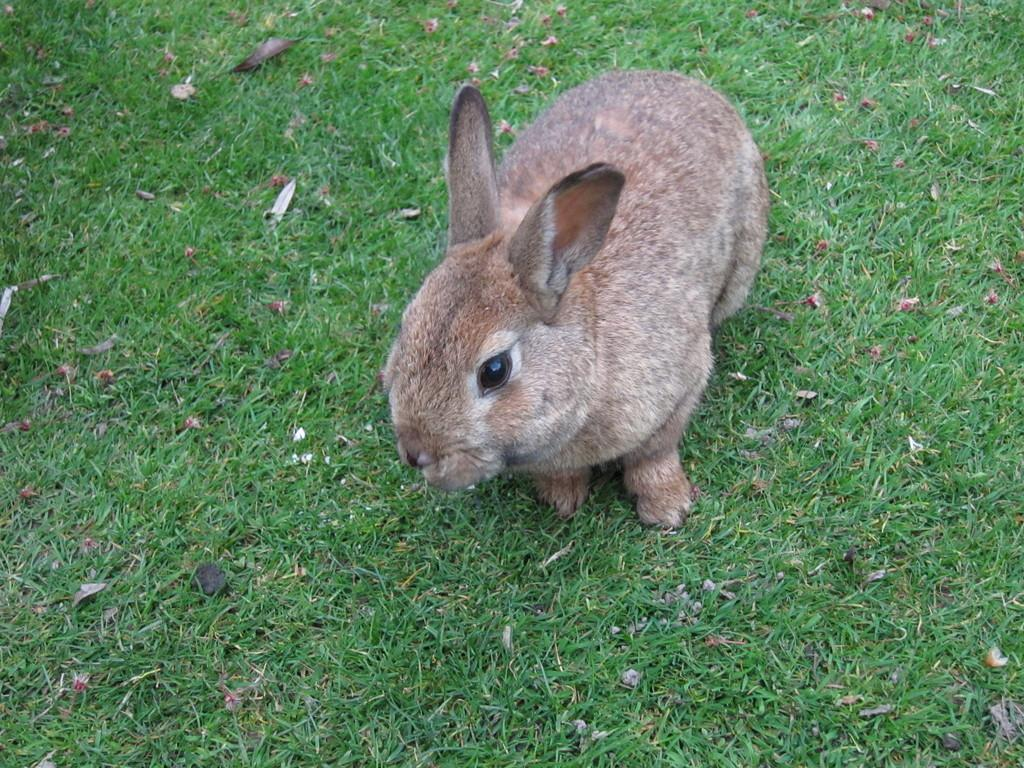What animal is present in the image? There is a rabbit in the image. What is the rabbit standing on? The rabbit is on grass. Can you describe the possible location of the image? The image may have been taken in a park. What is the rabbit's digestion process like in the image? The image does not provide information about the rabbit's digestion process. 